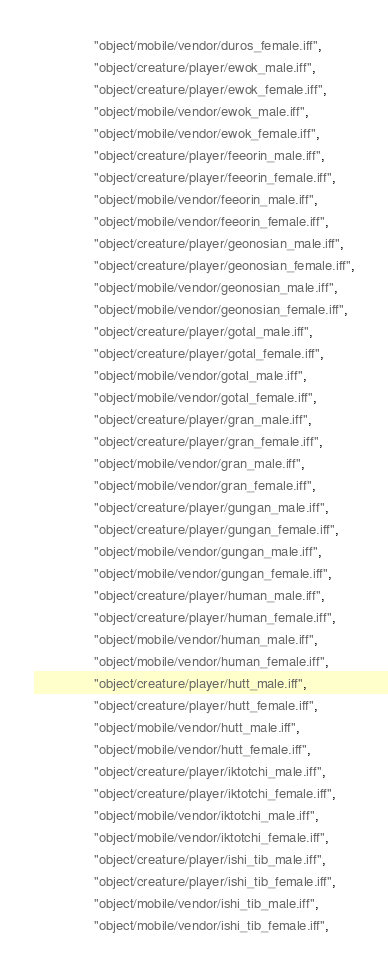Convert code to text. <code><loc_0><loc_0><loc_500><loc_500><_Lua_>				"object/mobile/vendor/duros_female.iff",
				"object/creature/player/ewok_male.iff",
				"object/creature/player/ewok_female.iff",
				"object/mobile/vendor/ewok_male.iff",
				"object/mobile/vendor/ewok_female.iff",
				"object/creature/player/feeorin_male.iff",
				"object/creature/player/feeorin_female.iff",
				"object/mobile/vendor/feeorin_male.iff",
				"object/mobile/vendor/feeorin_female.iff",
				"object/creature/player/geonosian_male.iff",
				"object/creature/player/geonosian_female.iff",
				"object/mobile/vendor/geonosian_male.iff",
				"object/mobile/vendor/geonosian_female.iff",
				"object/creature/player/gotal_male.iff",
				"object/creature/player/gotal_female.iff",
				"object/mobile/vendor/gotal_male.iff",
				"object/mobile/vendor/gotal_female.iff",
				"object/creature/player/gran_male.iff",
				"object/creature/player/gran_female.iff",
				"object/mobile/vendor/gran_male.iff",
				"object/mobile/vendor/gran_female.iff",
				"object/creature/player/gungan_male.iff",
				"object/creature/player/gungan_female.iff",
				"object/mobile/vendor/gungan_male.iff",
				"object/mobile/vendor/gungan_female.iff",
				"object/creature/player/human_male.iff",
				"object/creature/player/human_female.iff",
				"object/mobile/vendor/human_male.iff",
				"object/mobile/vendor/human_female.iff",
				"object/creature/player/hutt_male.iff",
				"object/creature/player/hutt_female.iff",
				"object/mobile/vendor/hutt_male.iff",
				"object/mobile/vendor/hutt_female.iff",
				"object/creature/player/iktotchi_male.iff",
				"object/creature/player/iktotchi_female.iff",
				"object/mobile/vendor/iktotchi_male.iff",
				"object/mobile/vendor/iktotchi_female.iff",
				"object/creature/player/ishi_tib_male.iff",
				"object/creature/player/ishi_tib_female.iff",
				"object/mobile/vendor/ishi_tib_male.iff",
				"object/mobile/vendor/ishi_tib_female.iff",</code> 